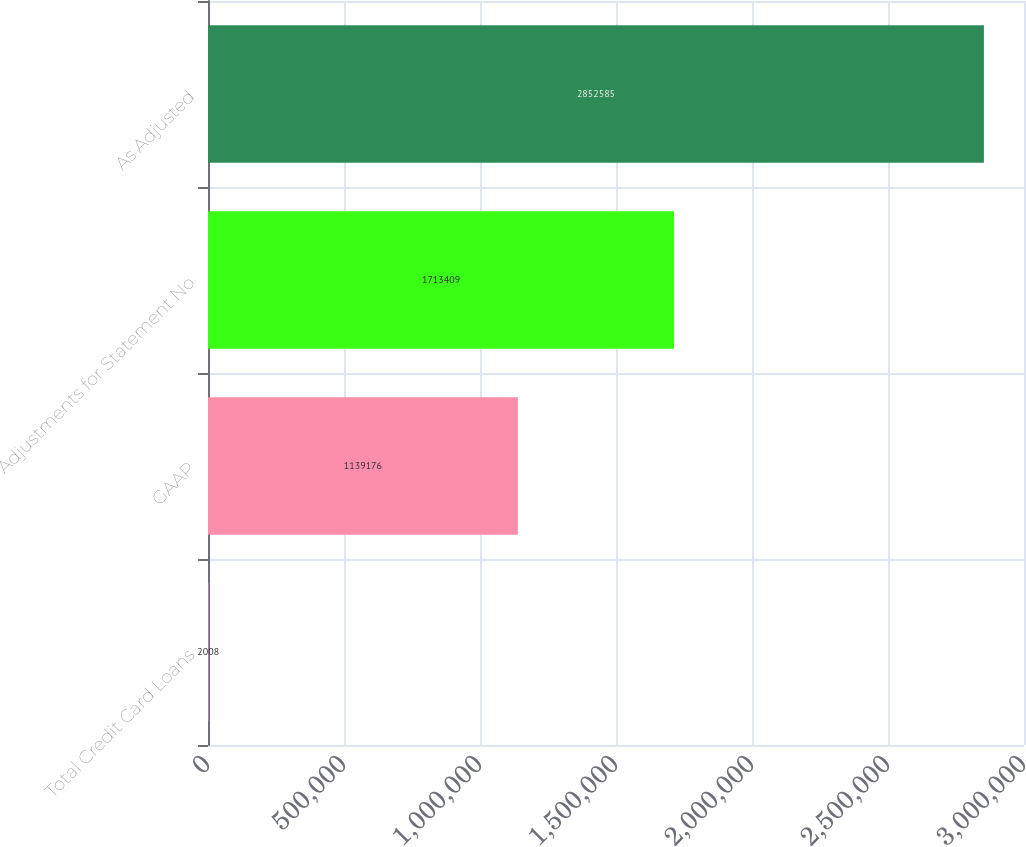Convert chart to OTSL. <chart><loc_0><loc_0><loc_500><loc_500><bar_chart><fcel>Total Credit Card Loans<fcel>GAAP<fcel>Adjustments for Statement No<fcel>As Adjusted<nl><fcel>2008<fcel>1.13918e+06<fcel>1.71341e+06<fcel>2.85258e+06<nl></chart> 